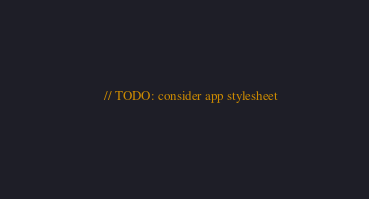<code> <loc_0><loc_0><loc_500><loc_500><_C++_>    // TODO: consider app stylesheet</code> 